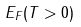<formula> <loc_0><loc_0><loc_500><loc_500>E _ { F } ( T > 0 )</formula> 